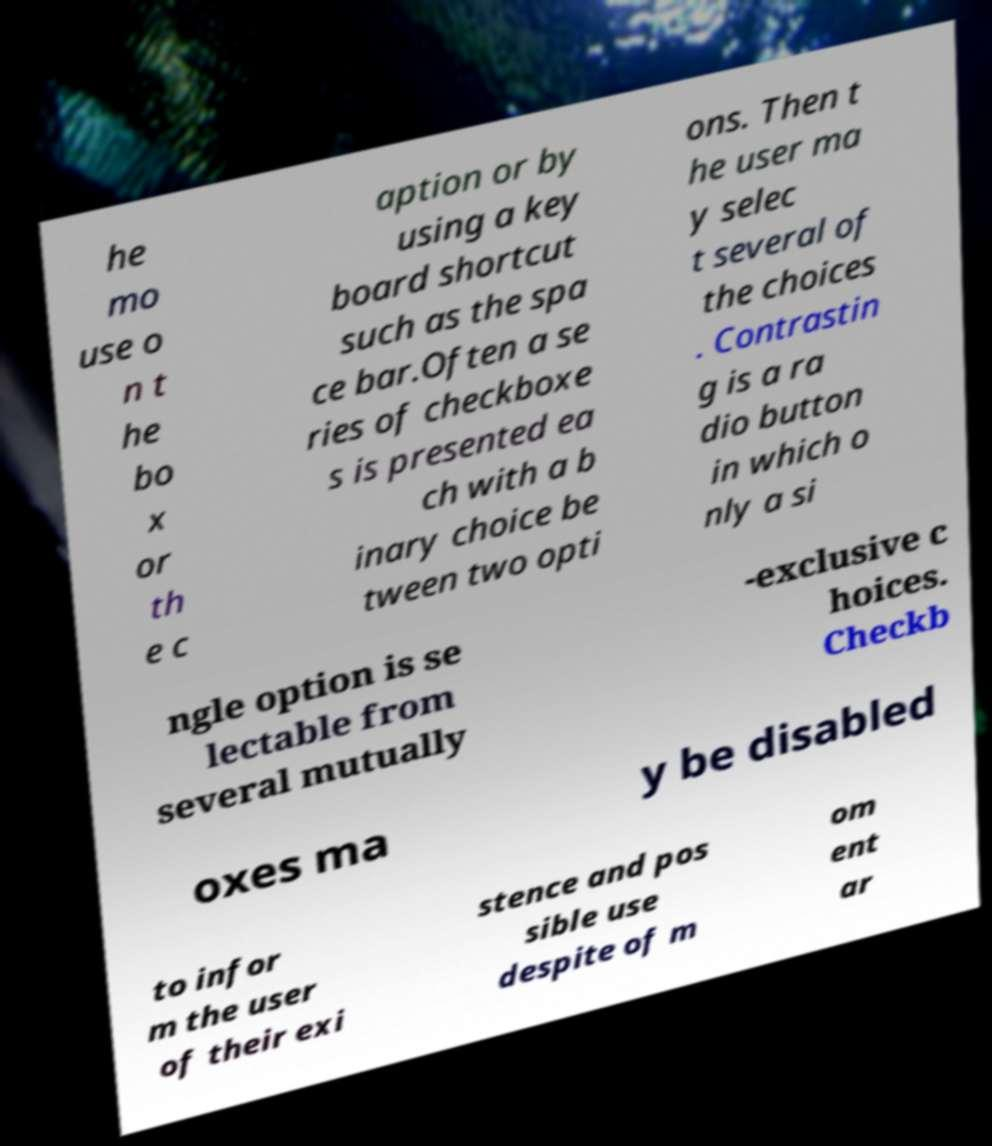Could you assist in decoding the text presented in this image and type it out clearly? he mo use o n t he bo x or th e c aption or by using a key board shortcut such as the spa ce bar.Often a se ries of checkboxe s is presented ea ch with a b inary choice be tween two opti ons. Then t he user ma y selec t several of the choices . Contrastin g is a ra dio button in which o nly a si ngle option is se lectable from several mutually -exclusive c hoices. Checkb oxes ma y be disabled to infor m the user of their exi stence and pos sible use despite of m om ent ar 